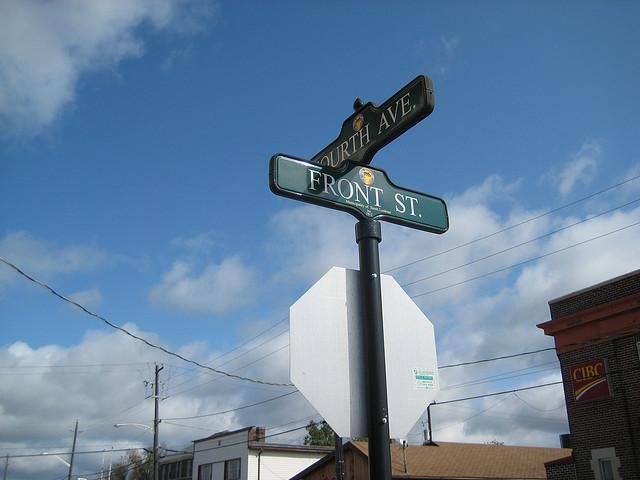How many signs are on the pole?
Keep it brief. 3. What streets are crossing?
Concise answer only. Fourth and front. What does the bottom-left sign say?
Keep it brief. Front st. What color is the pole holding the sign?
Answer briefly. Black. Is the sky clear?
Short answer required. Yes. What colors are on the sign on the left?
Give a very brief answer. Green and white. 